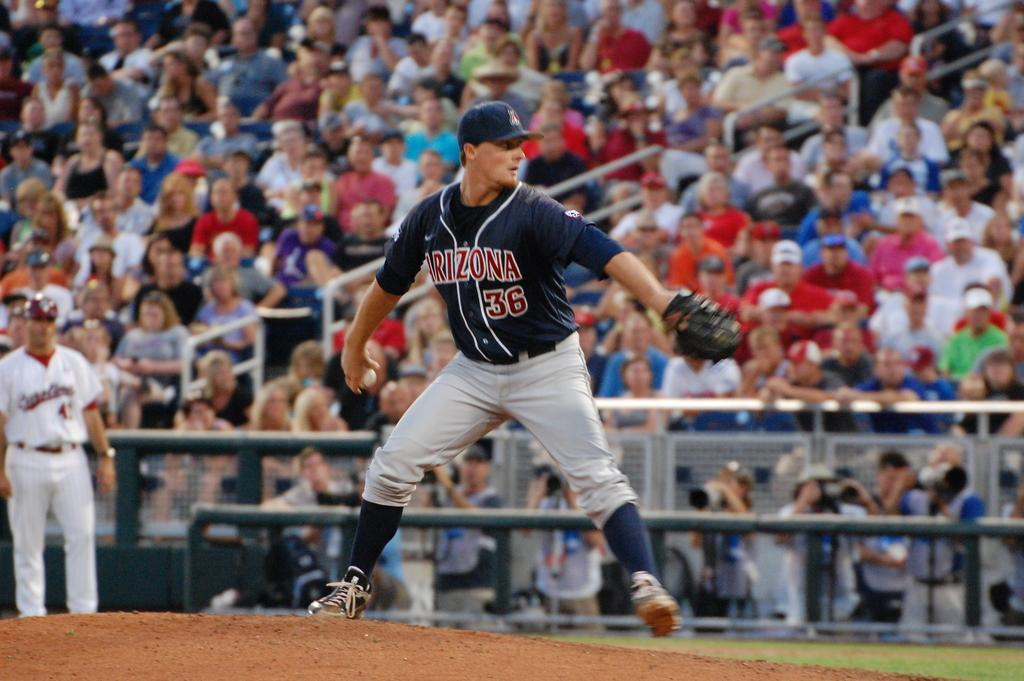<image>
Share a concise interpretation of the image provided. The player about to throw the ball wears the number 36 on his top. 